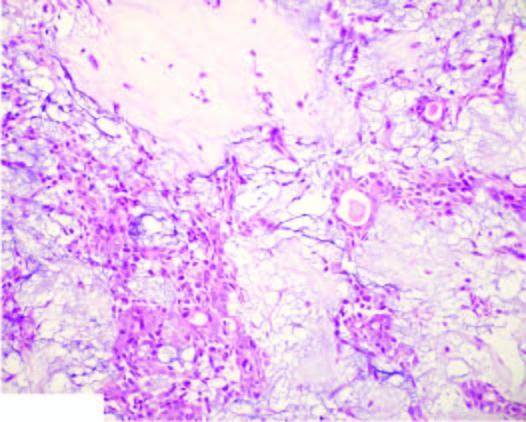s the epithelial element comprised of ducts, acini, tubules, sheets and strands of cuboidal and myoepithelial cells?
Answer the question using a single word or phrase. Yes 